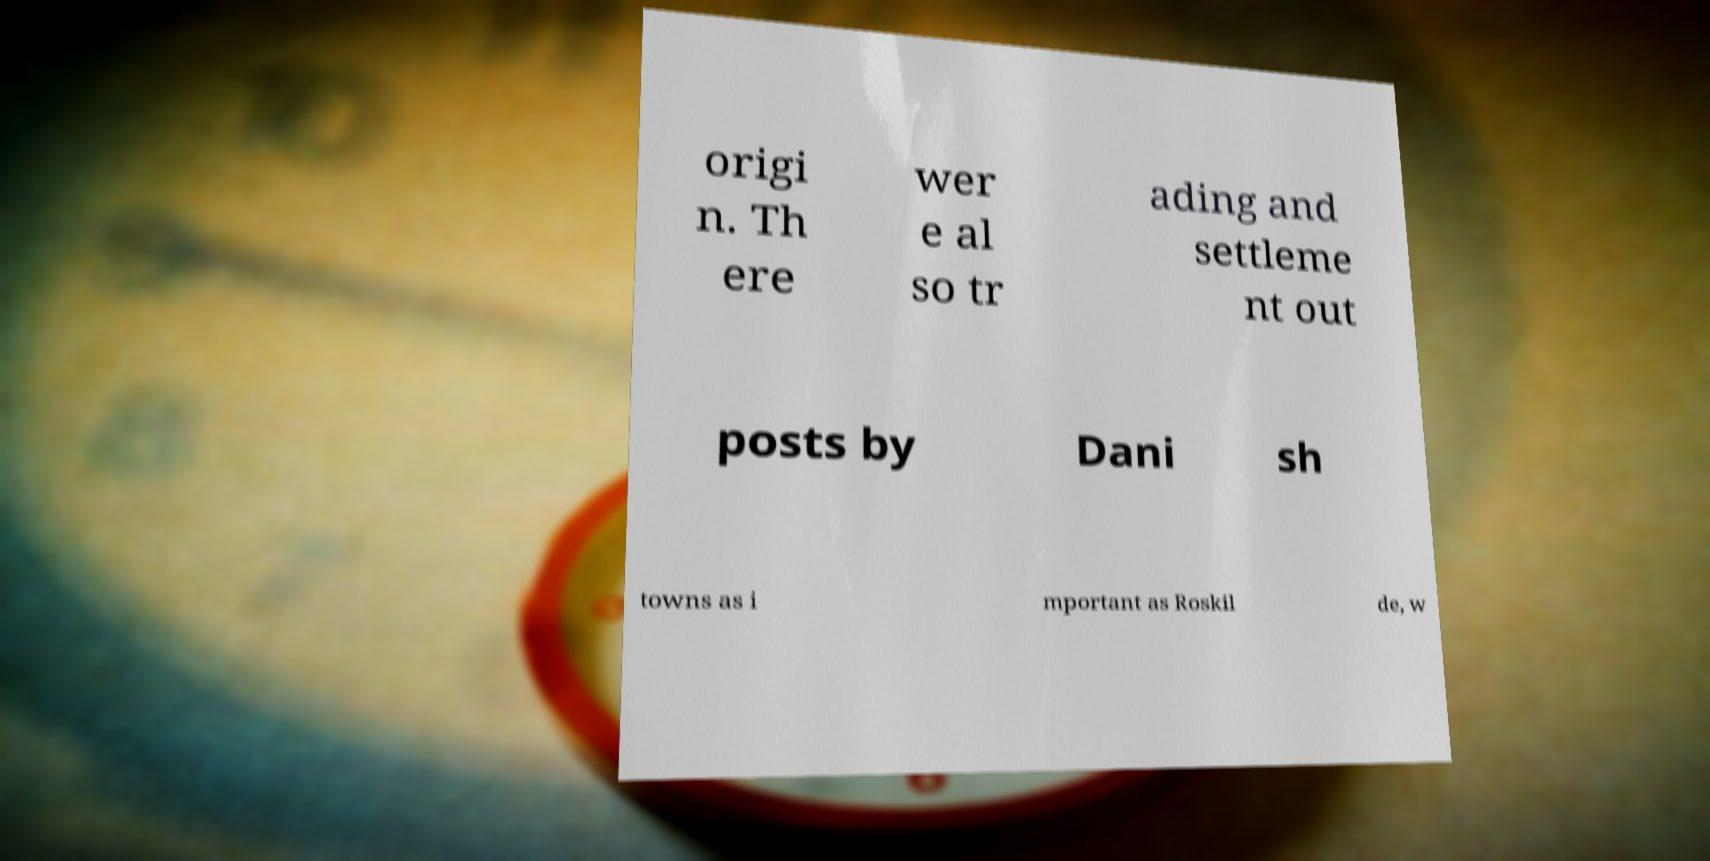Could you assist in decoding the text presented in this image and type it out clearly? origi n. Th ere wer e al so tr ading and settleme nt out posts by Dani sh towns as i mportant as Roskil de, w 